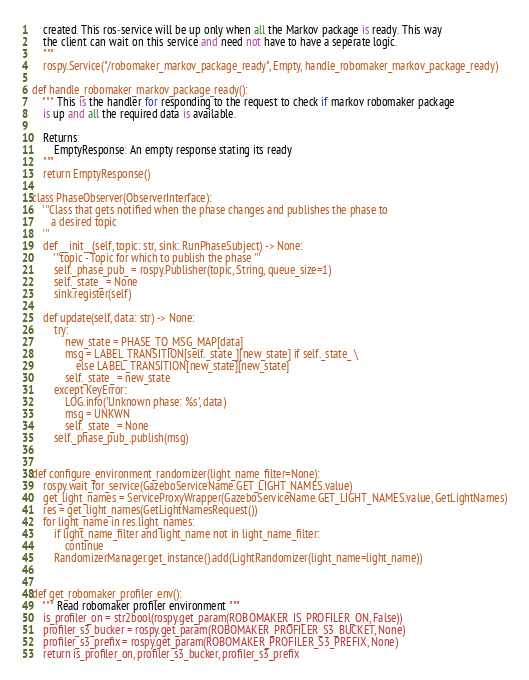<code> <loc_0><loc_0><loc_500><loc_500><_Python_>    created. This ros-service will be up only when all the Markov package is ready. This way
    the client can wait on this service and need not have to have a seperate logic.
    """
    rospy.Service("/robomaker_markov_package_ready", Empty, handle_robomaker_markov_package_ready)

def handle_robomaker_markov_package_ready():
    """ This is the handler for responding to the request to check if markov robomaker package
    is up and all the required data is available.

    Returns:
        EmptyResponse: An empty response stating its ready
    """
    return EmptyResponse()

class PhaseObserver(ObserverInterface):
    '''Class that gets notified when the phase changes and publishes the phase to
       a desired topic
    '''
    def __init__(self, topic: str, sink: RunPhaseSubject) -> None:
        '''topic - Topic for which to publish the phase '''
        self._phase_pub_ = rospy.Publisher(topic, String, queue_size=1)
        self._state_ = None
        sink.register(self)

    def update(self, data: str) -> None:
        try:
            new_state = PHASE_TO_MSG_MAP[data]
            msg = LABEL_TRANSITION[self._state_][new_state] if self._state_ \
                else LABEL_TRANSITION[new_state][new_state]
            self._state_ = new_state
        except KeyError:
            LOG.info('Unknown phase: %s', data)
            msg = UNKWN
            self._state_ = None
        self._phase_pub_.publish(msg)


def configure_environment_randomizer(light_name_filter=None):
    rospy.wait_for_service(GazeboServiceName.GET_LIGHT_NAMES.value)
    get_light_names = ServiceProxyWrapper(GazeboServiceName.GET_LIGHT_NAMES.value, GetLightNames)
    res = get_light_names(GetLightNamesRequest())
    for light_name in res.light_names:
        if light_name_filter and light_name not in light_name_filter:
            continue
        RandomizerManager.get_instance().add(LightRandomizer(light_name=light_name))


def get_robomaker_profiler_env():
    """ Read robomaker profiler environment """
    is_profiler_on = str2bool(rospy.get_param(ROBOMAKER_IS_PROFILER_ON, False))
    profiler_s3_bucker = rospy.get_param(ROBOMAKER_PROFILER_S3_BUCKET, None)
    profiler_s3_prefix = rospy.get_param(ROBOMAKER_PROFILER_S3_PREFIX, None)
    return is_profiler_on, profiler_s3_bucker, profiler_s3_prefix
</code> 